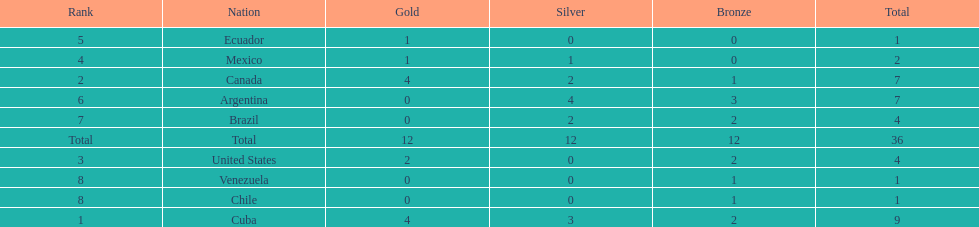How many total medals did brazil received? 4. 